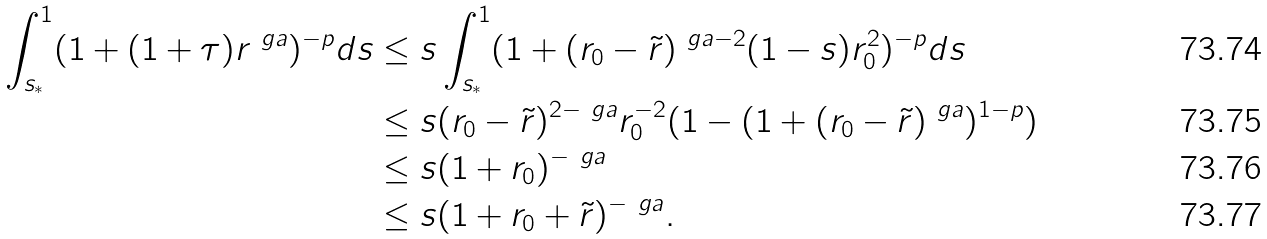<formula> <loc_0><loc_0><loc_500><loc_500>\int _ { s _ { * } } ^ { 1 } ( 1 + ( 1 + \tau ) r ^ { \ g a } ) ^ { - p } d s & \leq s \int _ { s _ { * } } ^ { 1 } ( 1 + ( r _ { 0 } - \tilde { r } ) ^ { \ g a - 2 } ( 1 - s ) r _ { 0 } ^ { 2 } ) ^ { - p } d s \\ & \leq s ( r _ { 0 } - \tilde { r } ) ^ { 2 - \ g a } r _ { 0 } ^ { - 2 } ( 1 - ( 1 + ( r _ { 0 } - \tilde { r } ) ^ { \ g a } ) ^ { 1 - p } ) \\ & \leq s ( 1 + r _ { 0 } ) ^ { - \ g a } \\ & \leq s ( 1 + r _ { 0 } + \tilde { r } ) ^ { - \ g a } .</formula> 